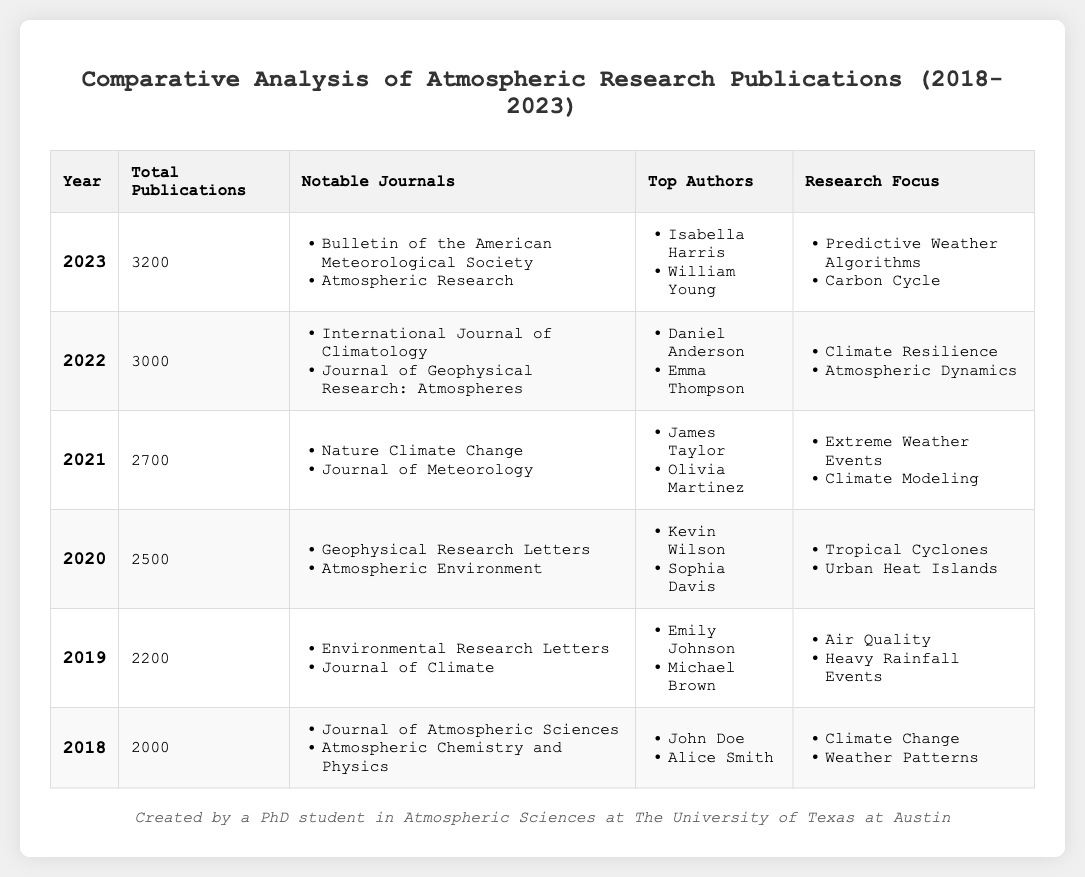What year had the highest number of total publications? By examining the "Total Publications" column, 2023 has the highest value at 3200 publications compared to the other years, which have lower totals.
Answer: 2023 Which notable journal was featured both in 2018 and 2022? The "Notable Journals" for 2018 includes "Atmospheric Chemistry and Physics," and for 2022, the journals include "Journal of Geophysical Research: Atmospheres." Comparing these lists, no journal is repeated.
Answer: None How many more publications were there in 2021 compared to 2019? 2021 had 2700 publications, while 2019 had 2200. The difference is calculated as 2700 - 2200 = 500.
Answer: 500 List the top authors for 2020. The "Top Authors" for 2020 are listed as "Kevin Wilson" and "Sophia Davis." This information can be directly retrieved from the table.
Answer: Kevin Wilson, Sophia Davis What is the average number of publications from 2018 to 2023? The total publications from 2018 to 2023 are 2000 + 2200 + 2500 + 2700 + 3000 + 3200 = 15600. There are 6 years, so the average is calculated as 15600 / 6 = 2600.
Answer: 2600 Did the total publications increase every year from 2018 to 2023? Sequentially reviewing the total publications in the table shows that each year has a greater total than the previous year, indicating consistent growth.
Answer: Yes Which research focus was predominant in 2021 and what was the number of publications that year? The main research focuses in 2021 include "Extreme Weather Events" and "Climate Modeling." The total publications for that year were 2700, directly obtainable from the table.
Answer: Extreme Weather Events, Climate Modeling; 2700 In which year did "Air Quality" feature as a research focus and what was the total number of publications that year? "Air Quality" is noted as a research focus for 2019, and the total publications recorded for that year were 2200. This information can be found in the respective rows of the table.
Answer: 2019; 2200 If we consider the top authors from 2021 and 2022, how many distinct authors are listed between both years? The top authors for 2021 are "James Taylor" and "Olivia Martinez," while for 2022, they are "Daniel Anderson" and "Emma Thompson." There are no overlapping authors, resulting in a total of 4 distinct authors when combined.
Answer: 4 What trend can be inferred from the growth of total publications from 2018 to 2023? Observing the values, there is a consistent increase in total publications each year, indicating a growing interest and output in atmospheric sciences research.
Answer: Increasing trend 